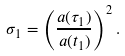Convert formula to latex. <formula><loc_0><loc_0><loc_500><loc_500>\sigma _ { 1 } = \left ( \frac { a ( \tau _ { 1 } ) } { a ( t _ { 1 } ) } \right ) ^ { 2 } .</formula> 